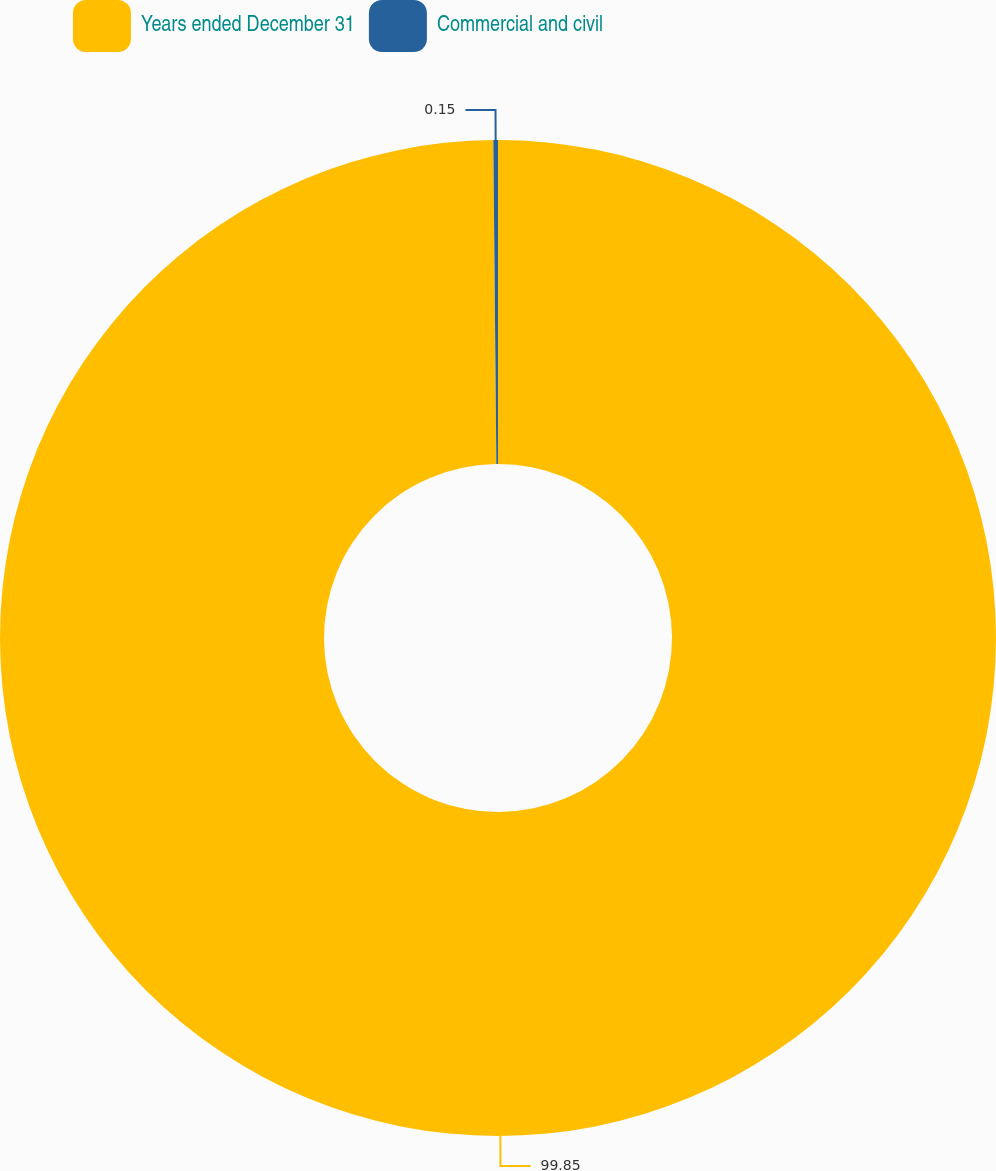Convert chart to OTSL. <chart><loc_0><loc_0><loc_500><loc_500><pie_chart><fcel>Years ended December 31<fcel>Commercial and civil<nl><fcel>99.85%<fcel>0.15%<nl></chart> 